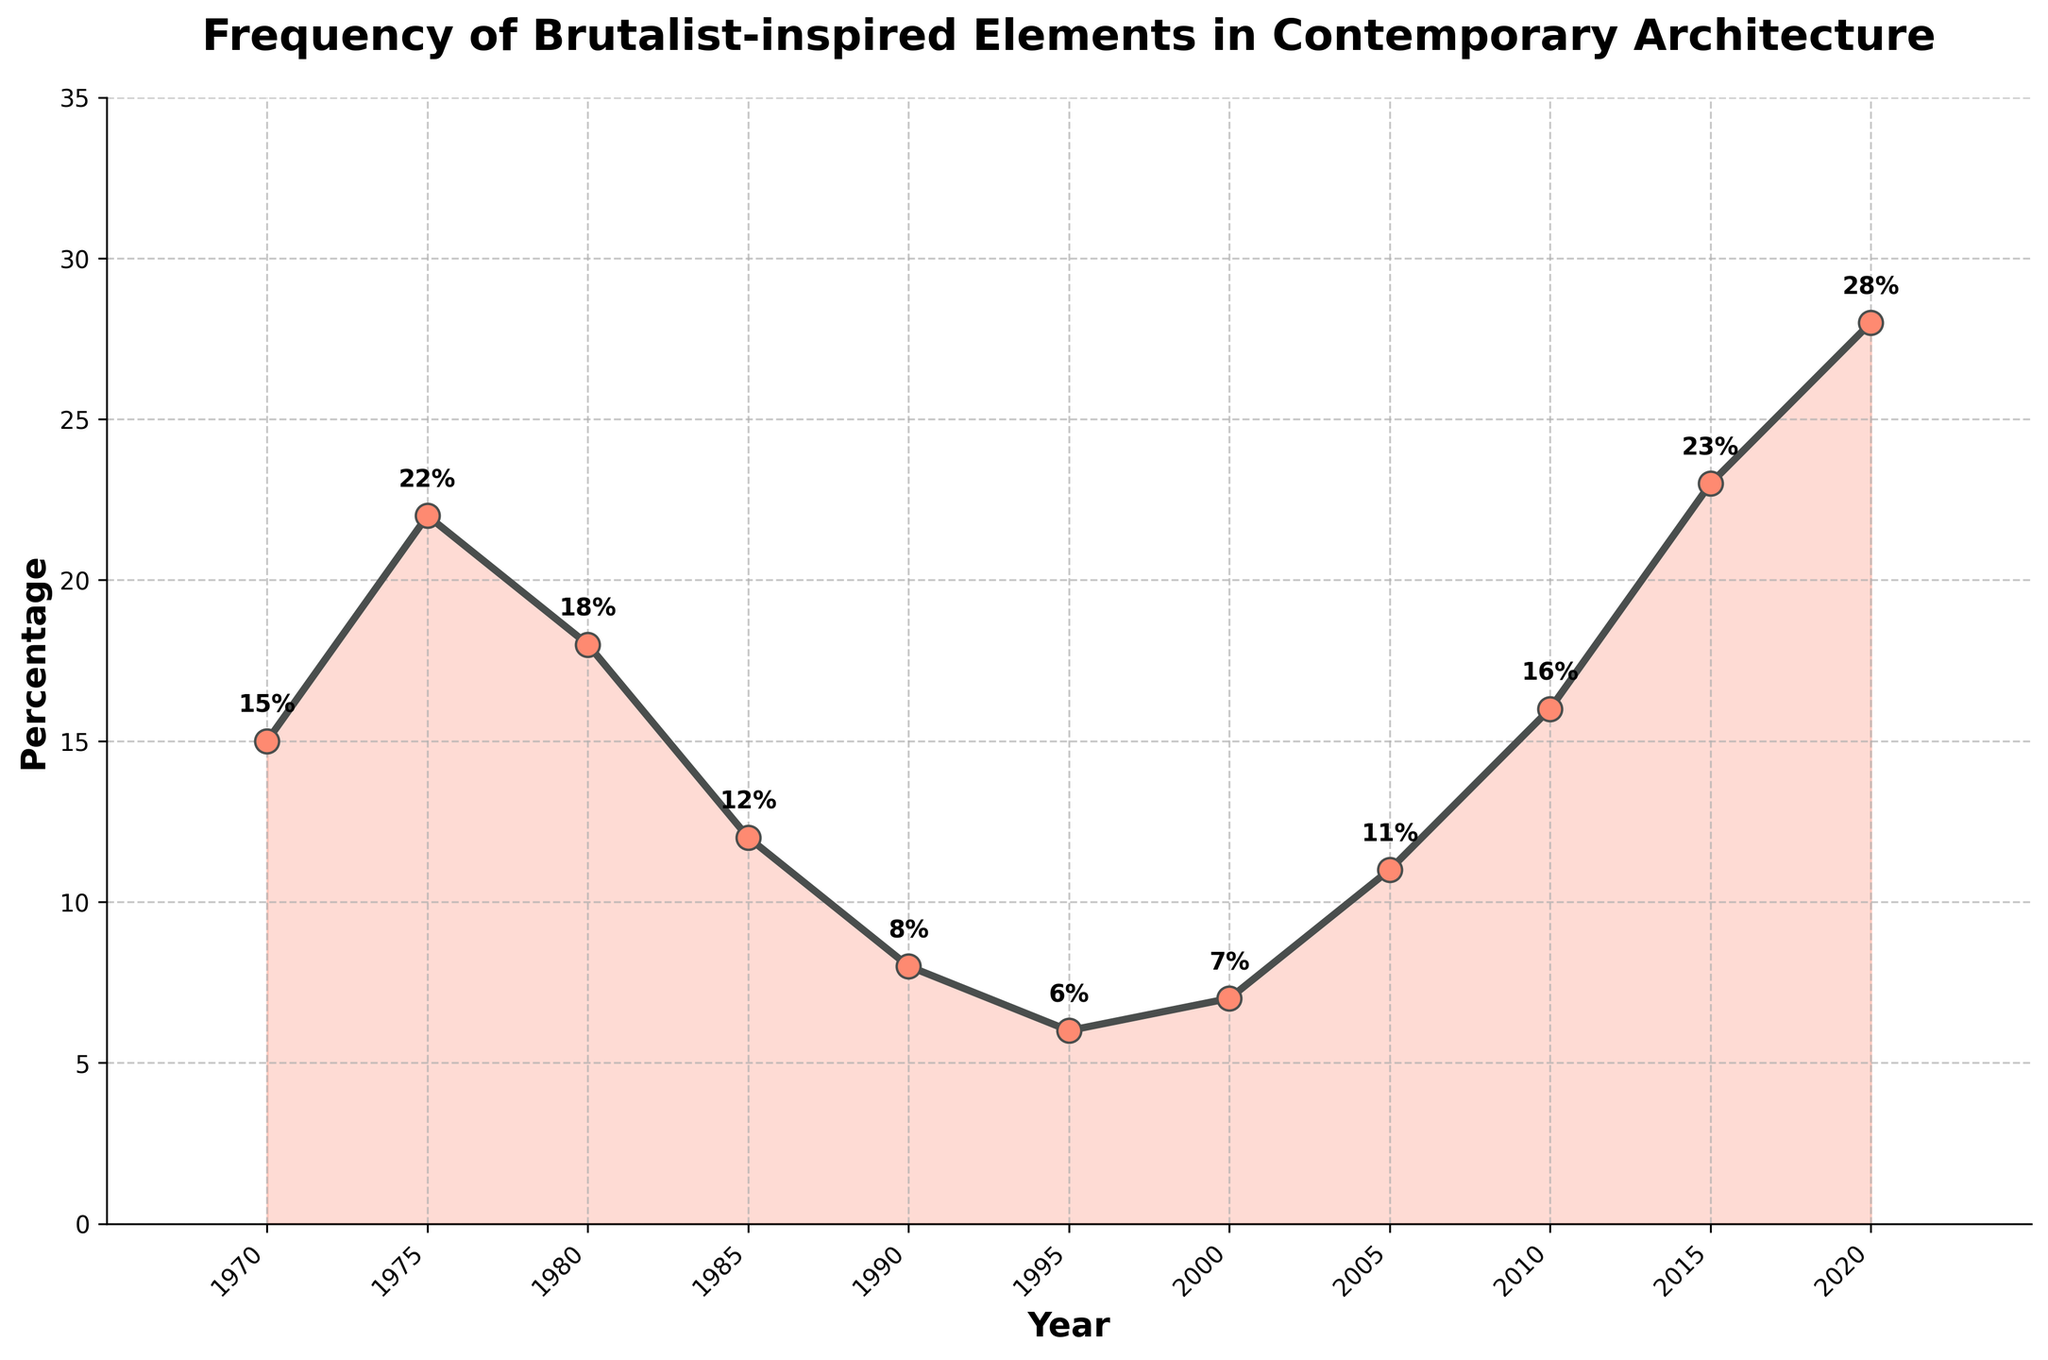What is the overall trend of the frequency of Brutalist-inspired elements from 1970 to 2020? The plot shows fluctuations over the decades, with an initial rise from 1970 to 1975, a decline until 2000, and then a significant rise from 2000 onwards.
Answer: Increasing overall with fluctuations What was the percentage change in Brutalist-inspired elements between 1980 and 1985? The percentage in 1980 was 18%, and in 1985 it was 12%. The change is calculated by (12 - 18) = -6%.
Answer: -6% In which year did the frequency of Brutalist-inspired elements peak? The peak occurred at the highest percentage point on the chart. The highest point is in 2020 at 28%.
Answer: 2020 Which decade experienced the most dramatic decline in Brutalist-inspired elements? From the graph, the steepest decline can be seen between 1980 and 1990, dropping from 18% to 8%.
Answer: 1980 to 1990 How does the frequency in 1975 compare to 2010? In 1975, the percentage was 22%, while in 2010 it was 16%. 1975 is higher than 2010.
Answer: 1975 > 2010 What is the average frequency of Brutalist-inspired elements from 1970 to 2020? The sum of percentages from 1970 to 2020 is (15 + 22 + 18 + 12 + 8 + 6 + 7 + 11 + 16 + 23 + 28) = 166. There are 11 years in the data, so the average is 166/11 ≈ 15.09%.
Answer: 15.09% Between which consecutive years was the most significant increase observed? The largest increase is observed by comparing changes between consecutive years, and it occurs between 2015 (23%) and 2020 (28%). The change is 5 percentage points.
Answer: 2015 to 2020 Which color is used to fill the area under the line in the chart? Observing the visual attributes, the filled area under the line is shaded in a light red color.
Answer: Light red How many years had a percentage of Brutalist-inspired elements equal or above 20%? By checking the values, the years with percentages equal or above 20% are 1975, 2015, and 2020, making a total of 3 years.
Answer: 3 years 